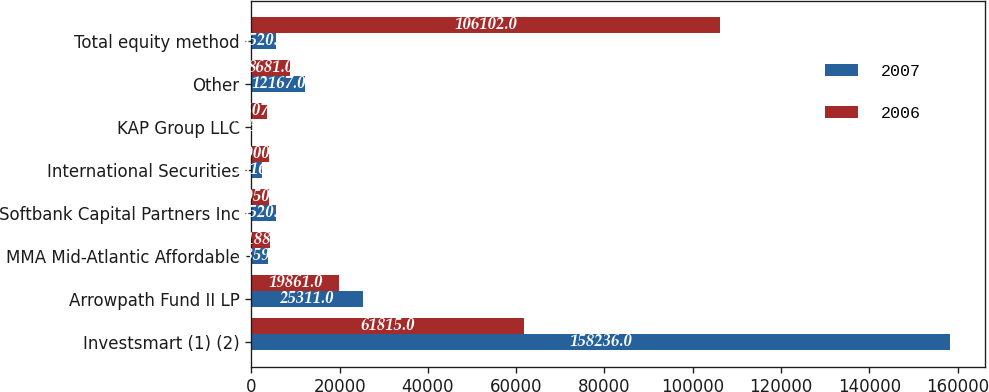Convert chart. <chart><loc_0><loc_0><loc_500><loc_500><stacked_bar_chart><ecel><fcel>Investsmart (1) (2)<fcel>Arrowpath Fund II LP<fcel>MMA Mid-Atlantic Affordable<fcel>Softbank Capital Partners Inc<fcel>International Securities<fcel>KAP Group LLC<fcel>Other<fcel>Total equity method<nl><fcel>2007<fcel>158236<fcel>25311<fcel>3859<fcel>5520<fcel>2516<fcel>225<fcel>12167<fcel>5520<nl><fcel>2006<fcel>61815<fcel>19861<fcel>4188<fcel>4050<fcel>4000<fcel>3507<fcel>8681<fcel>106102<nl></chart> 